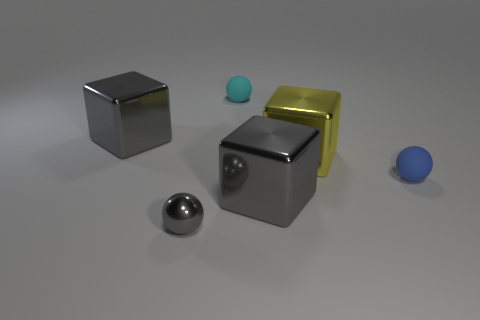Add 2 large yellow spheres. How many objects exist? 8 Subtract 1 cyan balls. How many objects are left? 5 Subtract all gray objects. Subtract all tiny gray shiny things. How many objects are left? 2 Add 4 tiny cyan matte balls. How many tiny cyan matte balls are left? 5 Add 6 big metallic things. How many big metallic things exist? 9 